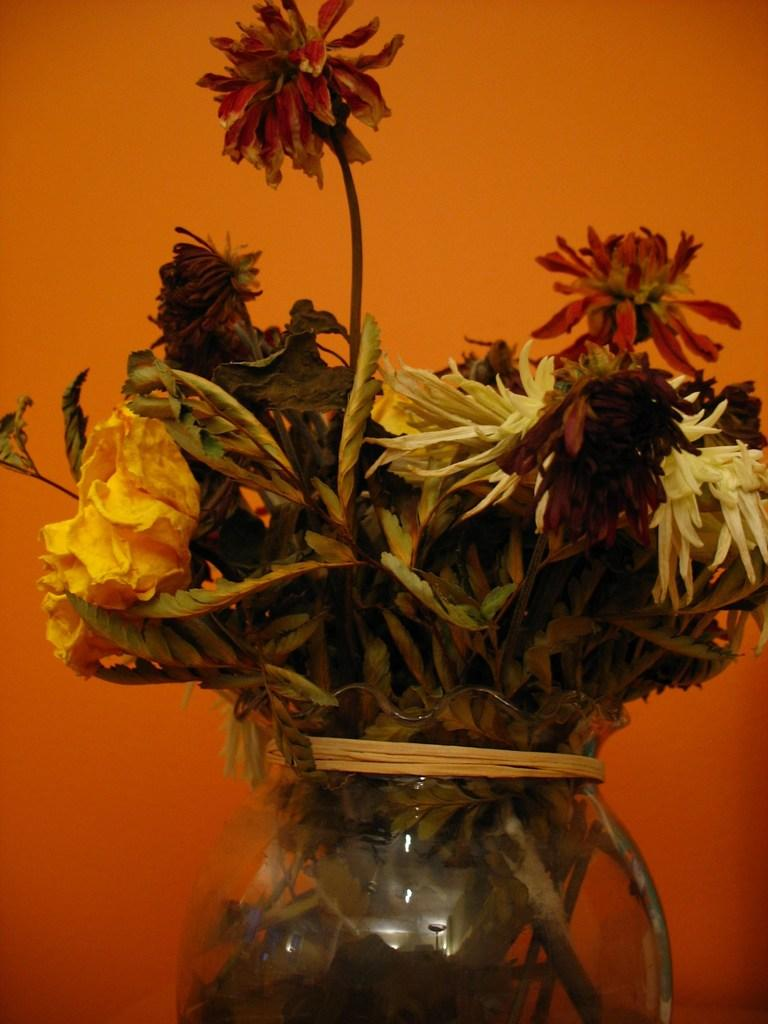Where was the image taken? The image was taken indoors. What can be seen in the background of the image? There is a wall in the background of the image. What is the main subject in the middle of the image? There is a flower vase in the middle of the image. What is inside the flower vase? The flower vase contains flowers. What type of sand can be seen on the floor in the image? There is no sand visible on the floor in the image. Is there a zebra present in the image? No, there is no zebra present in the image. 